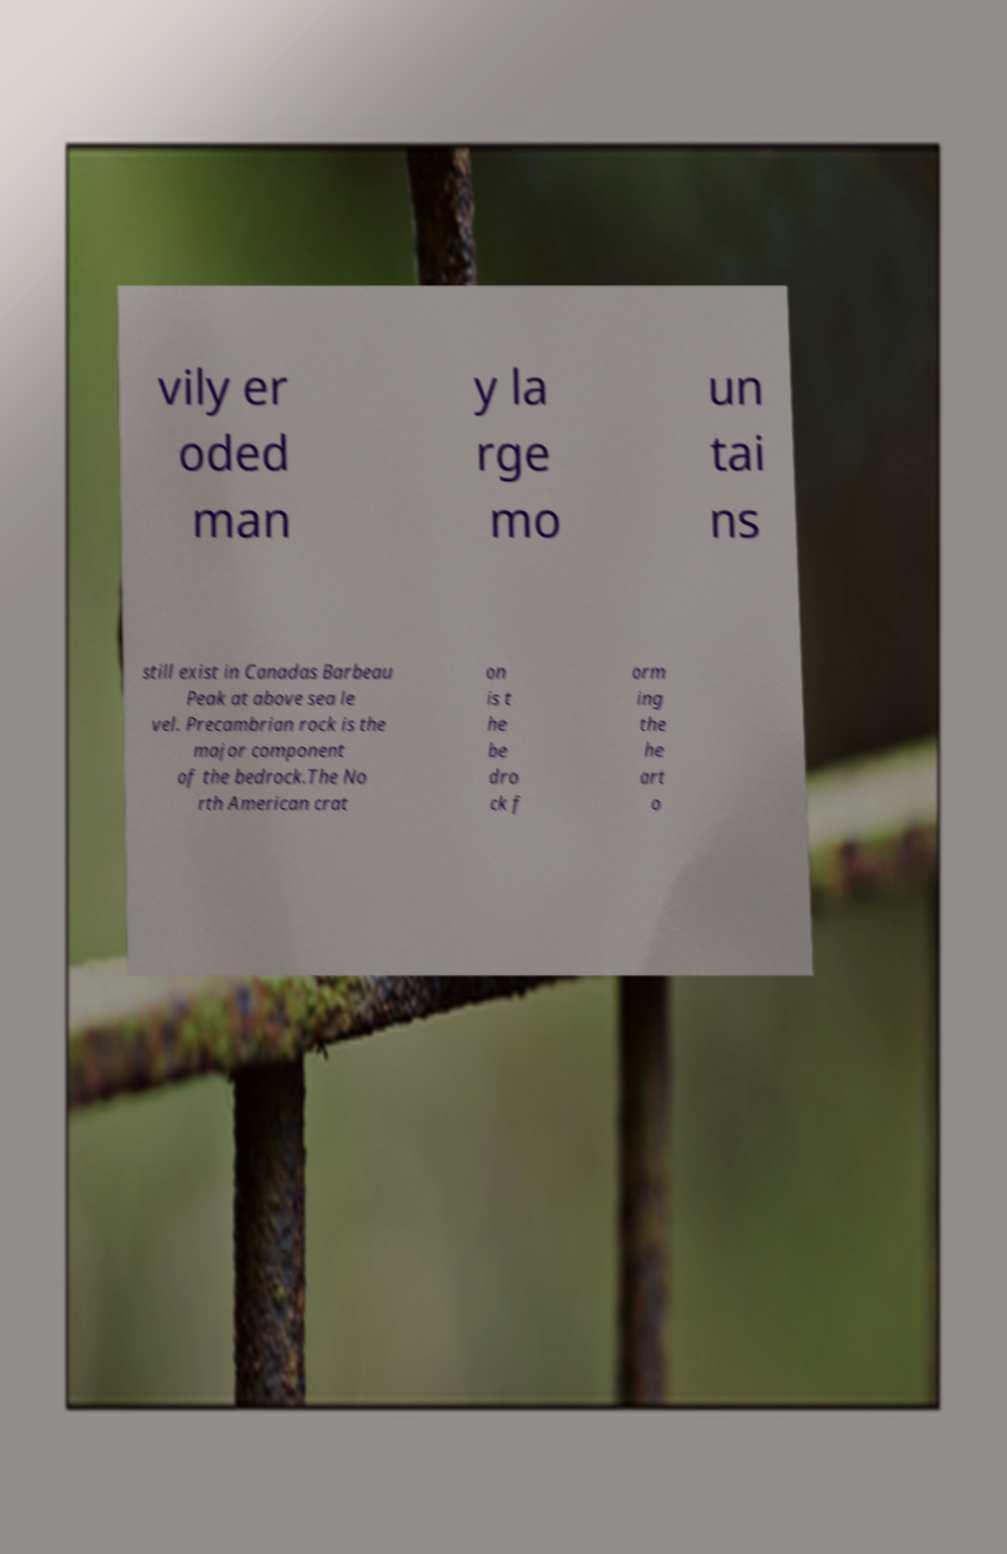Could you assist in decoding the text presented in this image and type it out clearly? vily er oded man y la rge mo un tai ns still exist in Canadas Barbeau Peak at above sea le vel. Precambrian rock is the major component of the bedrock.The No rth American crat on is t he be dro ck f orm ing the he art o 